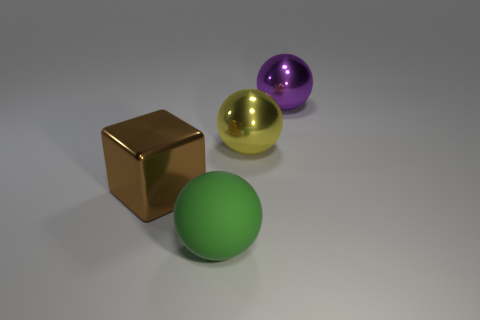Subtract all shiny balls. How many balls are left? 1 Subtract all yellow spheres. How many spheres are left? 2 Subtract 1 spheres. How many spheres are left? 2 Subtract all balls. How many objects are left? 1 Add 2 big yellow cylinders. How many objects exist? 6 Subtract all gray balls. Subtract all brown cubes. How many balls are left? 3 Subtract all big brown metallic cubes. Subtract all brown blocks. How many objects are left? 2 Add 2 large matte objects. How many large matte objects are left? 3 Add 4 yellow shiny balls. How many yellow shiny balls exist? 5 Subtract 1 purple spheres. How many objects are left? 3 